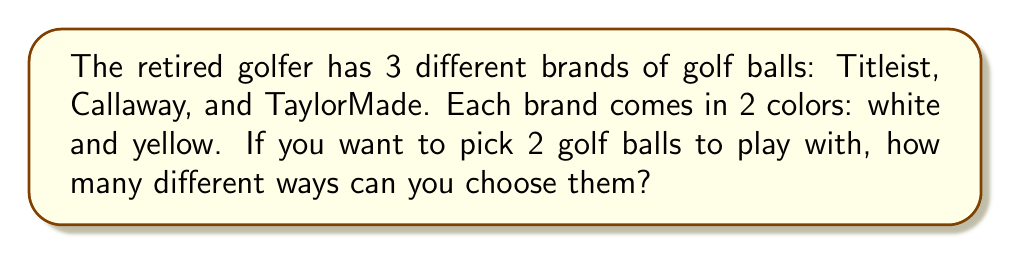Teach me how to tackle this problem. Let's approach this step-by-step:

1) First, let's count how many types of golf balls we have in total:
   - 3 brands (Titleist, Callaway, TaylorMade)
   - 2 colors for each brand (white and yellow)
   So, we have $3 \times 2 = 6$ different types of golf balls.

2) Now, we need to choose 2 golf balls from these 6 types. The order doesn't matter (choosing a white Titleist then a yellow Callaway is the same as choosing a yellow Callaway then a white Titleist).

3) This is a combination problem. We use the combination formula:

   $$C(n,r) = \frac{n!}{r!(n-r)!}$$

   Where $n$ is the total number of items to choose from, and $r$ is the number we're choosing.

4) In this case, $n = 6$ (total types of golf balls) and $r = 2$ (we're choosing 2).

5) Let's plug these numbers into our formula:

   $$C(6,2) = \frac{6!}{2!(6-2)!} = \frac{6!}{2!4!}$$

6) Expand this:
   $$\frac{6 \times 5 \times 4!}{2 \times 1 \times 4!}$$

7) The $4!$ cancels out in the numerator and denominator:
   $$\frac{6 \times 5}{2 \times 1} = \frac{30}{2} = 15$$

Therefore, there are 15 different ways to choose 2 golf balls from the available options.
Answer: 15 